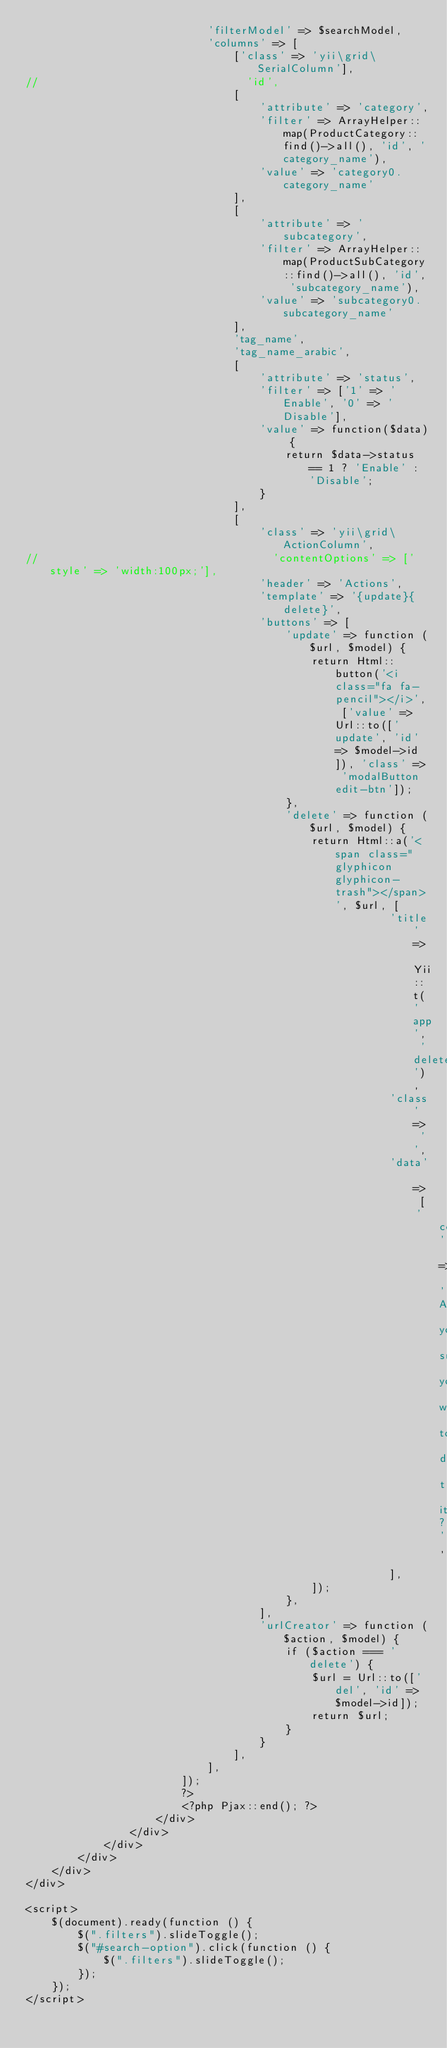Convert code to text. <code><loc_0><loc_0><loc_500><loc_500><_PHP_>                            'filterModel' => $searchModel,
                            'columns' => [
                                ['class' => 'yii\grid\SerialColumn'],
//                                'id',
                                [
                                    'attribute' => 'category',
                                    'filter' => ArrayHelper::map(ProductCategory::find()->all(), 'id', 'category_name'),
                                    'value' => 'category0.category_name'
                                ],
                                [
                                    'attribute' => 'subcategory',
                                    'filter' => ArrayHelper::map(ProductSubCategory::find()->all(), 'id', 'subcategory_name'),
                                    'value' => 'subcategory0.subcategory_name'
                                ],
                                'tag_name',
                                'tag_name_arabic',
                                [
                                    'attribute' => 'status',
                                    'filter' => ['1' => 'Enable', '0' => 'Disable'],
                                    'value' => function($data) {
                                        return $data->status == 1 ? 'Enable' : 'Disable';
                                    }
                                ],
                                [
                                    'class' => 'yii\grid\ActionColumn',
//                                    'contentOptions' => ['style' => 'width:100px;'],
                                    'header' => 'Actions',
                                    'template' => '{update}{delete}',
                                    'buttons' => [
                                        'update' => function ($url, $model) {
                                            return Html::button('<i class="fa fa-pencil"></i>', ['value' => Url::to(['update', 'id' => $model->id]), 'class' => 'modalButton edit-btn']);
                                        },
                                        'delete' => function ($url, $model) {
                                            return Html::a('<span class="glyphicon glyphicon-trash"></span>', $url, [
                                                        'title' => Yii::t('app', 'delete'),
                                                        'class' => '',
                                                        'data' => [
                                                            'confirm' => 'Are you sure you want to delete this item?',
                                                        ],
                                            ]);
                                        },
                                    ],
                                    'urlCreator' => function ($action, $model) {
                                        if ($action === 'delete') {
                                            $url = Url::to(['del', 'id' => $model->id]);
                                            return $url;
                                        }
                                    }
                                ],
                            ],
                        ]);
                        ?>
                        <?php Pjax::end(); ?>
                    </div>
                </div>
            </div>
        </div>
    </div>
</div>

<script>
    $(document).ready(function () {
        $(".filters").slideToggle();
        $("#search-option").click(function () {
            $(".filters").slideToggle();
        });
    });
</script>

</code> 